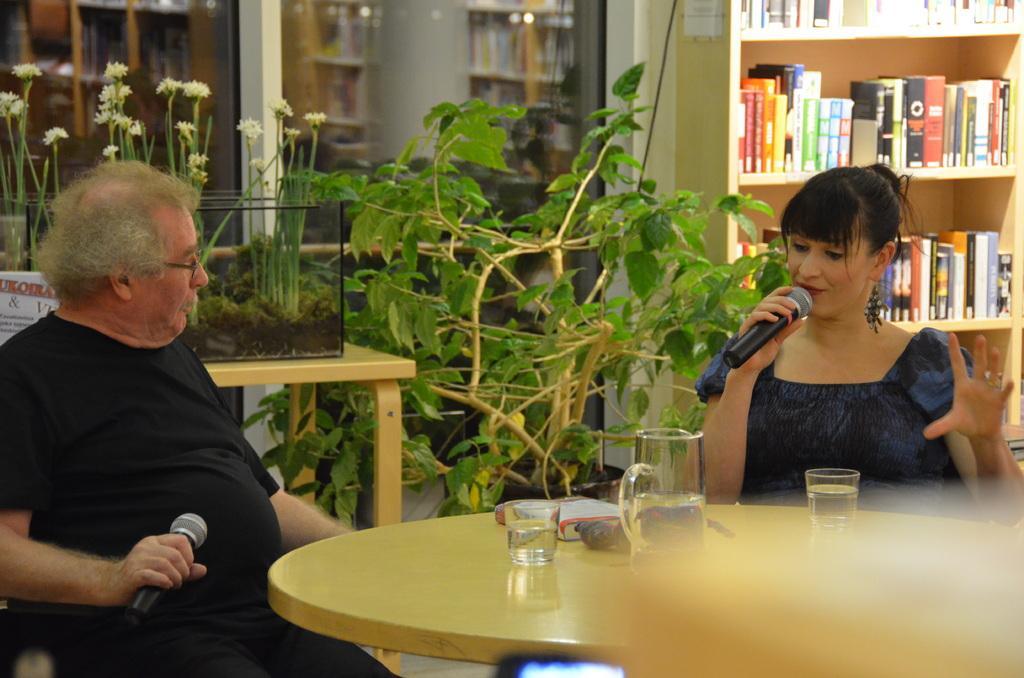In one or two sentences, can you explain what this image depicts? In this image I can see a man and a woman are sitting on chairs. I can also see both of them are holding mics in their hand. In the background I can see few plants, books in bookshelf. 